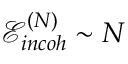<formula> <loc_0><loc_0><loc_500><loc_500>\mathcal { E } _ { i n c o h } ^ { ( N ) } \sim N</formula> 